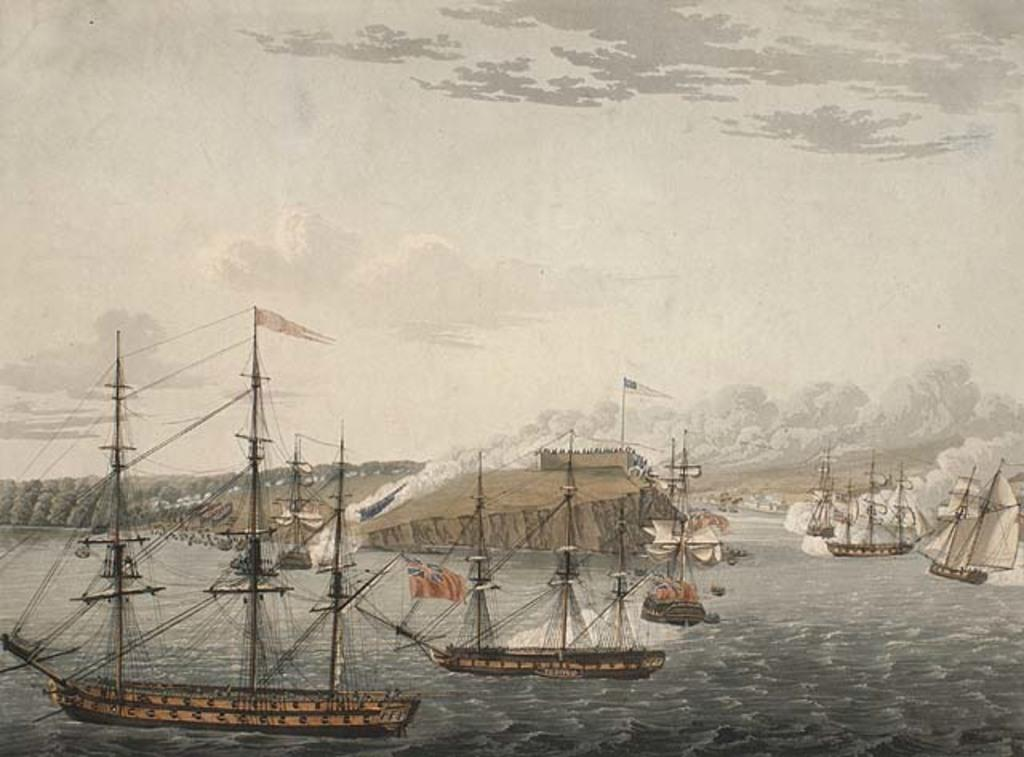What type of artwork is depicted in the image? The image is a painting. What can be seen in the water in the painting? There are boats in the water. Are there any distinguishing features on the boats? Yes, there are flags on the boats. What is visible in the sky in the painting? The sky is cloudy. What type of vegetation or greenery is present on the left side of the image? There is greenery on the left side of the image. What flavor of soda is being served on the boats in the image? There is no soda present in the image; it features boats with flags in the water and a cloudy sky. What is the purpose of the hand visible in the image? There is no hand visible in the image; it is a painting of boats, flags, and a cloudy sky. 